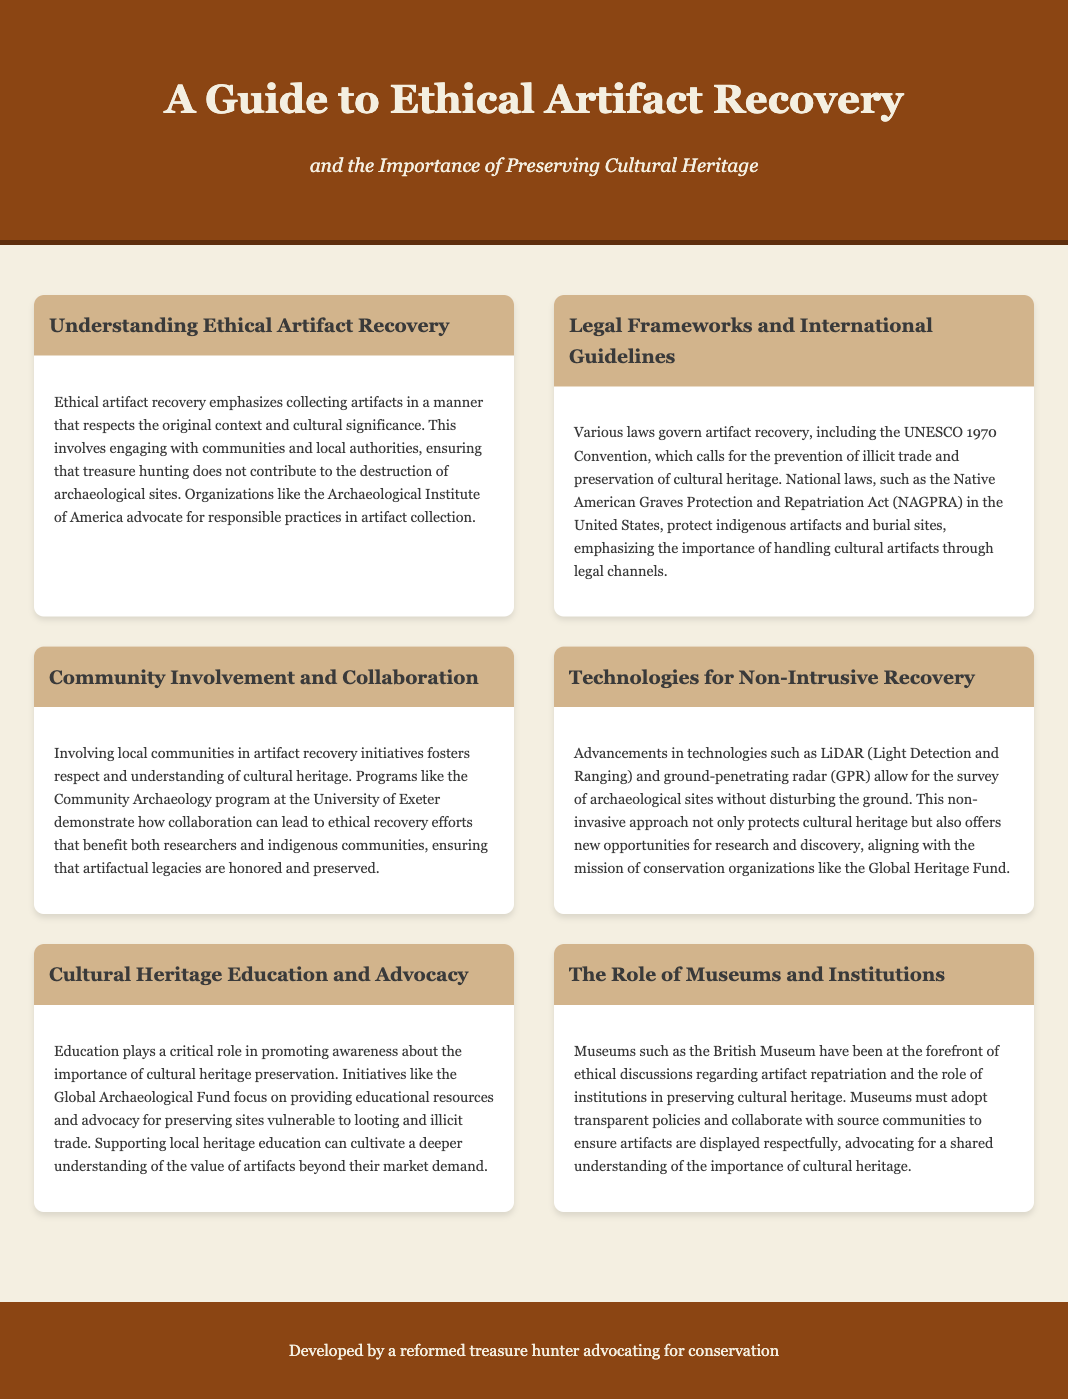What is the title of the guide? The title is found in the header of the document, prominently displayed.
Answer: A Guide to Ethical Artifact Recovery What organization advocates for responsible practices? This information is found in the section about ethical artifact recovery, which mentions a specific organization.
Answer: Archaeological Institute of America What does NAGPRA stand for? The document mentions this acronym in relation to national laws protecting indigenous artifacts.
Answer: Native American Graves Protection and Repatriation Act What technology is mentioned for non-intrusive recovery? This detail appears in the section discussing technologies for artifact recovery.
Answer: LiDAR What is a focus of the Global Archaeological Fund? This program is referenced in the context of cultural heritage education and advocacy.
Answer: Educational resources What do museums like the British Museum advocate for? This information is found in the section about the role of museums and institutions.
Answer: Artifact repatriation 